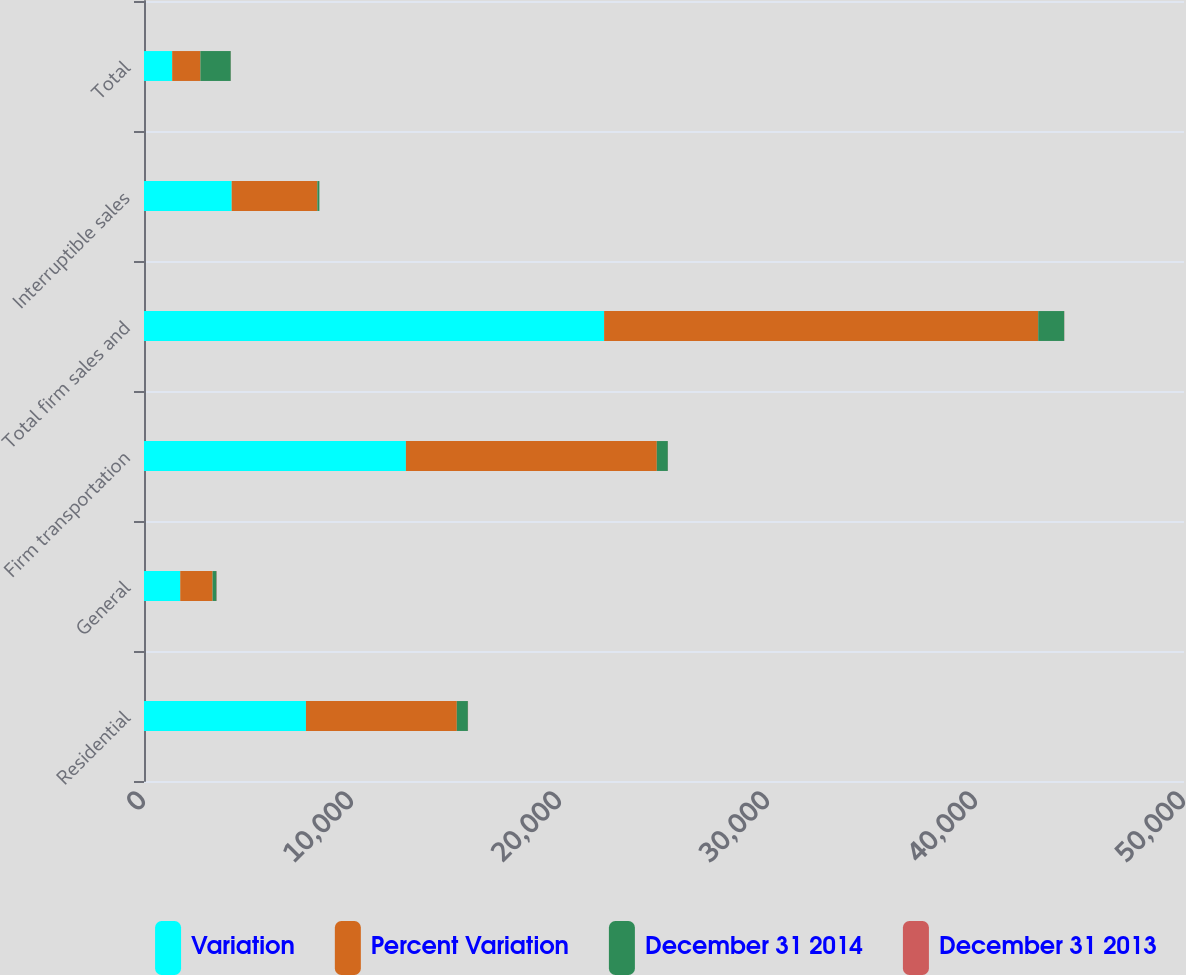Convert chart. <chart><loc_0><loc_0><loc_500><loc_500><stacked_bar_chart><ecel><fcel>Residential<fcel>General<fcel>Firm transportation<fcel>Total firm sales and<fcel>Interruptible sales<fcel>Total<nl><fcel>Variation<fcel>7786<fcel>1743<fcel>12592<fcel>22121<fcel>4216<fcel>1355.5<nl><fcel>Percent Variation<fcel>7253<fcel>1555<fcel>12062<fcel>20870<fcel>4118<fcel>1355.5<nl><fcel>December 31 2014<fcel>533<fcel>188<fcel>530<fcel>1251<fcel>98<fcel>1460<nl><fcel>December 31 2013<fcel>7.3<fcel>12.1<fcel>4.4<fcel>6<fcel>2.4<fcel>5.6<nl></chart> 